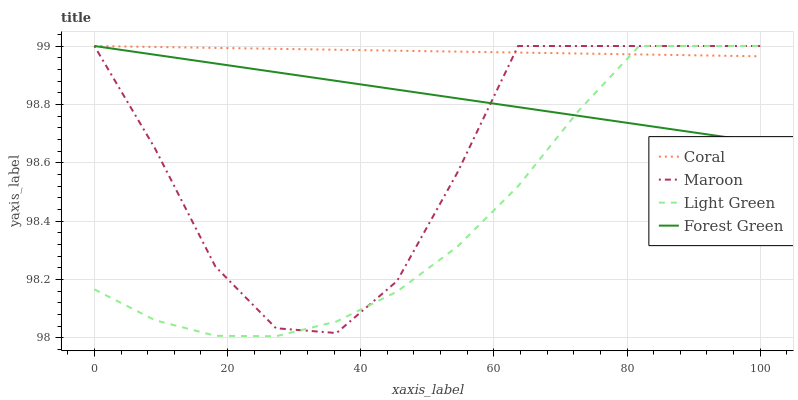Does Light Green have the minimum area under the curve?
Answer yes or no. Yes. Does Coral have the maximum area under the curve?
Answer yes or no. Yes. Does Coral have the minimum area under the curve?
Answer yes or no. No. Does Light Green have the maximum area under the curve?
Answer yes or no. No. Is Coral the smoothest?
Answer yes or no. Yes. Is Maroon the roughest?
Answer yes or no. Yes. Is Light Green the smoothest?
Answer yes or no. No. Is Light Green the roughest?
Answer yes or no. No. Does Light Green have the lowest value?
Answer yes or no. Yes. Does Coral have the lowest value?
Answer yes or no. No. Does Maroon have the highest value?
Answer yes or no. Yes. Does Forest Green intersect Coral?
Answer yes or no. Yes. Is Forest Green less than Coral?
Answer yes or no. No. Is Forest Green greater than Coral?
Answer yes or no. No. 